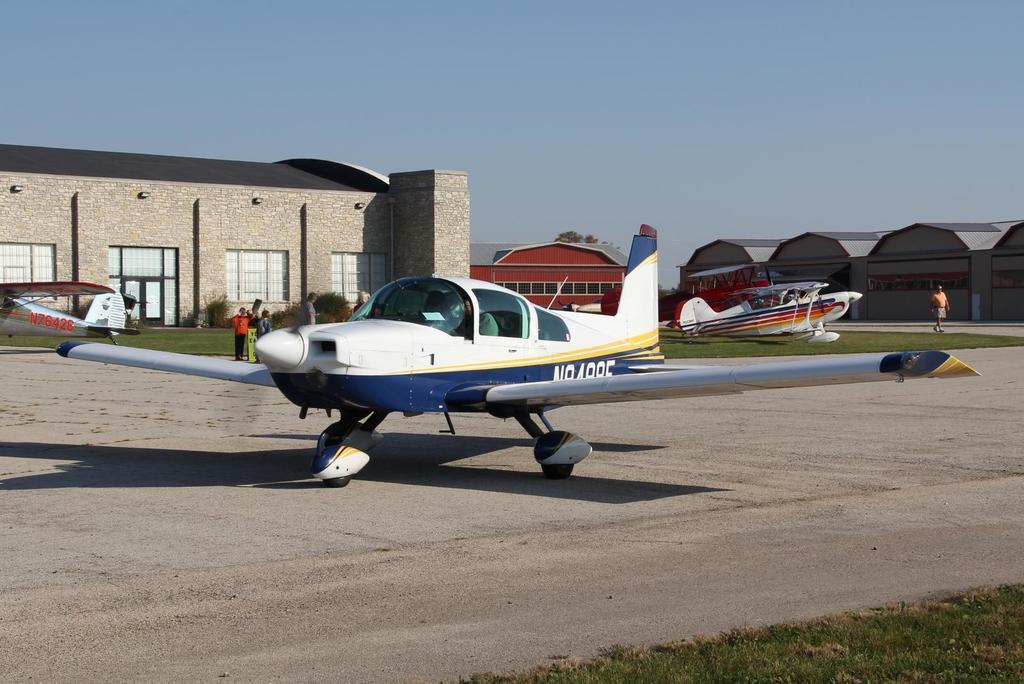Provide a one-sentence caption for the provided image. Silver N76426 plane sits in the background while another white and blue plane sits on the runway. 